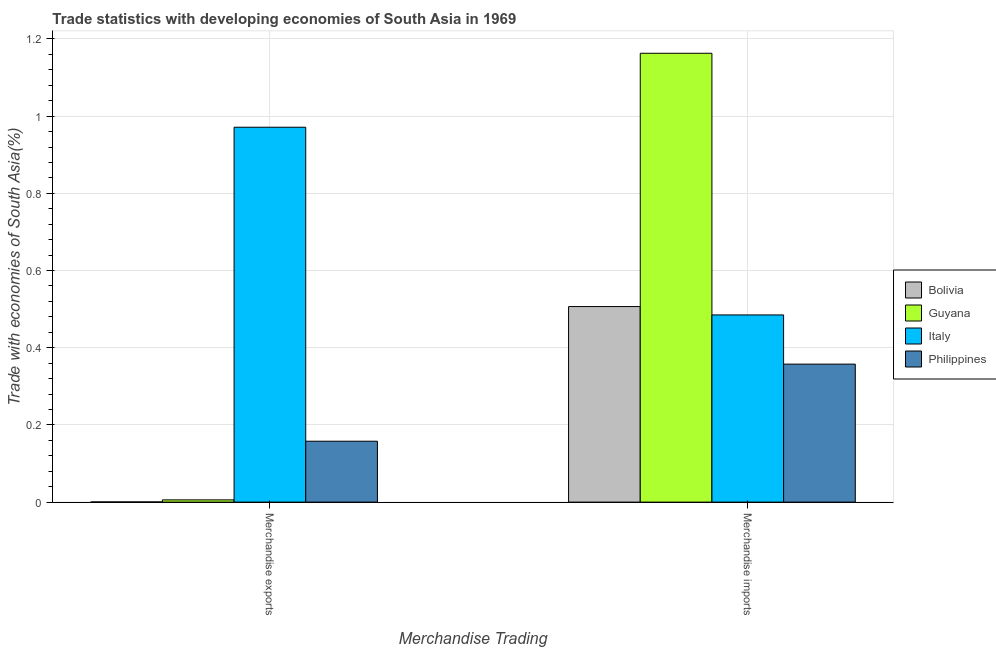How many different coloured bars are there?
Your answer should be compact. 4. How many bars are there on the 1st tick from the right?
Your response must be concise. 4. What is the merchandise exports in Bolivia?
Provide a succinct answer. 0. Across all countries, what is the maximum merchandise exports?
Provide a succinct answer. 0.97. Across all countries, what is the minimum merchandise exports?
Ensure brevity in your answer.  0. In which country was the merchandise imports maximum?
Provide a succinct answer. Guyana. In which country was the merchandise imports minimum?
Make the answer very short. Philippines. What is the total merchandise imports in the graph?
Provide a short and direct response. 2.51. What is the difference between the merchandise imports in Italy and that in Guyana?
Provide a short and direct response. -0.68. What is the difference between the merchandise exports in Philippines and the merchandise imports in Guyana?
Give a very brief answer. -1.01. What is the average merchandise imports per country?
Your answer should be very brief. 0.63. What is the difference between the merchandise exports and merchandise imports in Guyana?
Give a very brief answer. -1.16. In how many countries, is the merchandise exports greater than 0.6400000000000001 %?
Your answer should be very brief. 1. What is the ratio of the merchandise exports in Guyana to that in Philippines?
Ensure brevity in your answer.  0.04. What does the 2nd bar from the left in Merchandise imports represents?
Your answer should be compact. Guyana. Are all the bars in the graph horizontal?
Give a very brief answer. No. What is the difference between two consecutive major ticks on the Y-axis?
Make the answer very short. 0.2. Does the graph contain any zero values?
Keep it short and to the point. No. Does the graph contain grids?
Provide a succinct answer. Yes. How many legend labels are there?
Provide a short and direct response. 4. How are the legend labels stacked?
Keep it short and to the point. Vertical. What is the title of the graph?
Make the answer very short. Trade statistics with developing economies of South Asia in 1969. What is the label or title of the X-axis?
Your answer should be very brief. Merchandise Trading. What is the label or title of the Y-axis?
Offer a very short reply. Trade with economies of South Asia(%). What is the Trade with economies of South Asia(%) in Bolivia in Merchandise exports?
Make the answer very short. 0. What is the Trade with economies of South Asia(%) in Guyana in Merchandise exports?
Offer a terse response. 0.01. What is the Trade with economies of South Asia(%) of Italy in Merchandise exports?
Offer a terse response. 0.97. What is the Trade with economies of South Asia(%) of Philippines in Merchandise exports?
Your answer should be very brief. 0.16. What is the Trade with economies of South Asia(%) in Bolivia in Merchandise imports?
Provide a short and direct response. 0.51. What is the Trade with economies of South Asia(%) of Guyana in Merchandise imports?
Your response must be concise. 1.16. What is the Trade with economies of South Asia(%) in Italy in Merchandise imports?
Your answer should be very brief. 0.48. What is the Trade with economies of South Asia(%) in Philippines in Merchandise imports?
Provide a succinct answer. 0.36. Across all Merchandise Trading, what is the maximum Trade with economies of South Asia(%) of Bolivia?
Provide a short and direct response. 0.51. Across all Merchandise Trading, what is the maximum Trade with economies of South Asia(%) in Guyana?
Offer a terse response. 1.16. Across all Merchandise Trading, what is the maximum Trade with economies of South Asia(%) of Italy?
Your response must be concise. 0.97. Across all Merchandise Trading, what is the maximum Trade with economies of South Asia(%) of Philippines?
Offer a terse response. 0.36. Across all Merchandise Trading, what is the minimum Trade with economies of South Asia(%) of Bolivia?
Offer a very short reply. 0. Across all Merchandise Trading, what is the minimum Trade with economies of South Asia(%) of Guyana?
Make the answer very short. 0.01. Across all Merchandise Trading, what is the minimum Trade with economies of South Asia(%) of Italy?
Offer a very short reply. 0.48. Across all Merchandise Trading, what is the minimum Trade with economies of South Asia(%) in Philippines?
Ensure brevity in your answer.  0.16. What is the total Trade with economies of South Asia(%) in Bolivia in the graph?
Make the answer very short. 0.51. What is the total Trade with economies of South Asia(%) in Guyana in the graph?
Make the answer very short. 1.17. What is the total Trade with economies of South Asia(%) in Italy in the graph?
Make the answer very short. 1.46. What is the total Trade with economies of South Asia(%) of Philippines in the graph?
Provide a succinct answer. 0.52. What is the difference between the Trade with economies of South Asia(%) of Bolivia in Merchandise exports and that in Merchandise imports?
Provide a succinct answer. -0.51. What is the difference between the Trade with economies of South Asia(%) in Guyana in Merchandise exports and that in Merchandise imports?
Your answer should be compact. -1.16. What is the difference between the Trade with economies of South Asia(%) in Italy in Merchandise exports and that in Merchandise imports?
Provide a short and direct response. 0.49. What is the difference between the Trade with economies of South Asia(%) of Philippines in Merchandise exports and that in Merchandise imports?
Provide a short and direct response. -0.2. What is the difference between the Trade with economies of South Asia(%) in Bolivia in Merchandise exports and the Trade with economies of South Asia(%) in Guyana in Merchandise imports?
Ensure brevity in your answer.  -1.16. What is the difference between the Trade with economies of South Asia(%) of Bolivia in Merchandise exports and the Trade with economies of South Asia(%) of Italy in Merchandise imports?
Your response must be concise. -0.48. What is the difference between the Trade with economies of South Asia(%) of Bolivia in Merchandise exports and the Trade with economies of South Asia(%) of Philippines in Merchandise imports?
Your response must be concise. -0.36. What is the difference between the Trade with economies of South Asia(%) in Guyana in Merchandise exports and the Trade with economies of South Asia(%) in Italy in Merchandise imports?
Ensure brevity in your answer.  -0.48. What is the difference between the Trade with economies of South Asia(%) of Guyana in Merchandise exports and the Trade with economies of South Asia(%) of Philippines in Merchandise imports?
Give a very brief answer. -0.35. What is the difference between the Trade with economies of South Asia(%) in Italy in Merchandise exports and the Trade with economies of South Asia(%) in Philippines in Merchandise imports?
Offer a very short reply. 0.61. What is the average Trade with economies of South Asia(%) in Bolivia per Merchandise Trading?
Your response must be concise. 0.25. What is the average Trade with economies of South Asia(%) of Guyana per Merchandise Trading?
Your response must be concise. 0.58. What is the average Trade with economies of South Asia(%) in Italy per Merchandise Trading?
Make the answer very short. 0.73. What is the average Trade with economies of South Asia(%) in Philippines per Merchandise Trading?
Provide a succinct answer. 0.26. What is the difference between the Trade with economies of South Asia(%) of Bolivia and Trade with economies of South Asia(%) of Guyana in Merchandise exports?
Ensure brevity in your answer.  -0.01. What is the difference between the Trade with economies of South Asia(%) of Bolivia and Trade with economies of South Asia(%) of Italy in Merchandise exports?
Provide a short and direct response. -0.97. What is the difference between the Trade with economies of South Asia(%) in Bolivia and Trade with economies of South Asia(%) in Philippines in Merchandise exports?
Provide a succinct answer. -0.16. What is the difference between the Trade with economies of South Asia(%) in Guyana and Trade with economies of South Asia(%) in Italy in Merchandise exports?
Offer a terse response. -0.97. What is the difference between the Trade with economies of South Asia(%) of Guyana and Trade with economies of South Asia(%) of Philippines in Merchandise exports?
Your answer should be compact. -0.15. What is the difference between the Trade with economies of South Asia(%) in Italy and Trade with economies of South Asia(%) in Philippines in Merchandise exports?
Give a very brief answer. 0.81. What is the difference between the Trade with economies of South Asia(%) of Bolivia and Trade with economies of South Asia(%) of Guyana in Merchandise imports?
Ensure brevity in your answer.  -0.66. What is the difference between the Trade with economies of South Asia(%) of Bolivia and Trade with economies of South Asia(%) of Italy in Merchandise imports?
Your response must be concise. 0.02. What is the difference between the Trade with economies of South Asia(%) in Bolivia and Trade with economies of South Asia(%) in Philippines in Merchandise imports?
Your answer should be very brief. 0.15. What is the difference between the Trade with economies of South Asia(%) in Guyana and Trade with economies of South Asia(%) in Italy in Merchandise imports?
Give a very brief answer. 0.68. What is the difference between the Trade with economies of South Asia(%) in Guyana and Trade with economies of South Asia(%) in Philippines in Merchandise imports?
Keep it short and to the point. 0.81. What is the difference between the Trade with economies of South Asia(%) of Italy and Trade with economies of South Asia(%) of Philippines in Merchandise imports?
Your answer should be compact. 0.13. What is the ratio of the Trade with economies of South Asia(%) in Bolivia in Merchandise exports to that in Merchandise imports?
Make the answer very short. 0. What is the ratio of the Trade with economies of South Asia(%) of Guyana in Merchandise exports to that in Merchandise imports?
Your answer should be compact. 0.01. What is the ratio of the Trade with economies of South Asia(%) of Italy in Merchandise exports to that in Merchandise imports?
Give a very brief answer. 2. What is the ratio of the Trade with economies of South Asia(%) in Philippines in Merchandise exports to that in Merchandise imports?
Give a very brief answer. 0.44. What is the difference between the highest and the second highest Trade with economies of South Asia(%) in Bolivia?
Provide a short and direct response. 0.51. What is the difference between the highest and the second highest Trade with economies of South Asia(%) of Guyana?
Provide a short and direct response. 1.16. What is the difference between the highest and the second highest Trade with economies of South Asia(%) of Italy?
Your answer should be compact. 0.49. What is the difference between the highest and the second highest Trade with economies of South Asia(%) in Philippines?
Your answer should be compact. 0.2. What is the difference between the highest and the lowest Trade with economies of South Asia(%) of Bolivia?
Provide a succinct answer. 0.51. What is the difference between the highest and the lowest Trade with economies of South Asia(%) in Guyana?
Give a very brief answer. 1.16. What is the difference between the highest and the lowest Trade with economies of South Asia(%) in Italy?
Make the answer very short. 0.49. What is the difference between the highest and the lowest Trade with economies of South Asia(%) in Philippines?
Your response must be concise. 0.2. 